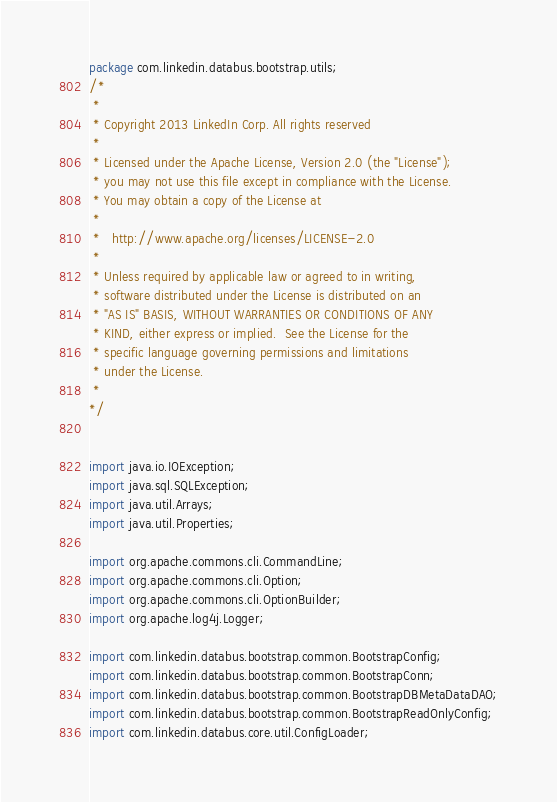Convert code to text. <code><loc_0><loc_0><loc_500><loc_500><_Java_>package com.linkedin.databus.bootstrap.utils;
/*
 *
 * Copyright 2013 LinkedIn Corp. All rights reserved
 *
 * Licensed under the Apache License, Version 2.0 (the "License");
 * you may not use this file except in compliance with the License.
 * You may obtain a copy of the License at
 *
 *   http://www.apache.org/licenses/LICENSE-2.0
 *
 * Unless required by applicable law or agreed to in writing,
 * software distributed under the License is distributed on an
 * "AS IS" BASIS, WITHOUT WARRANTIES OR CONDITIONS OF ANY
 * KIND, either express or implied.  See the License for the
 * specific language governing permissions and limitations
 * under the License.
 *
*/


import java.io.IOException;
import java.sql.SQLException;
import java.util.Arrays;
import java.util.Properties;

import org.apache.commons.cli.CommandLine;
import org.apache.commons.cli.Option;
import org.apache.commons.cli.OptionBuilder;
import org.apache.log4j.Logger;

import com.linkedin.databus.bootstrap.common.BootstrapConfig;
import com.linkedin.databus.bootstrap.common.BootstrapConn;
import com.linkedin.databus.bootstrap.common.BootstrapDBMetaDataDAO;
import com.linkedin.databus.bootstrap.common.BootstrapReadOnlyConfig;
import com.linkedin.databus.core.util.ConfigLoader;</code> 